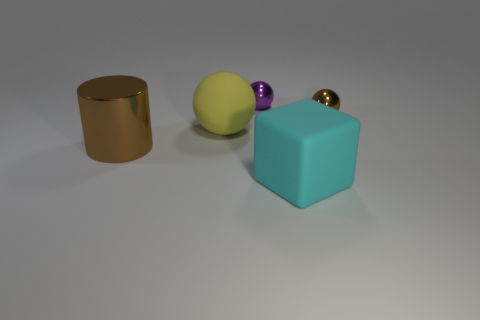Add 4 cyan matte cubes. How many objects exist? 9 Subtract all cylinders. How many objects are left? 4 Subtract 0 gray blocks. How many objects are left? 5 Subtract all small blue balls. Subtract all purple spheres. How many objects are left? 4 Add 1 large cyan rubber cubes. How many large cyan rubber cubes are left? 2 Add 4 big metallic objects. How many big metallic objects exist? 5 